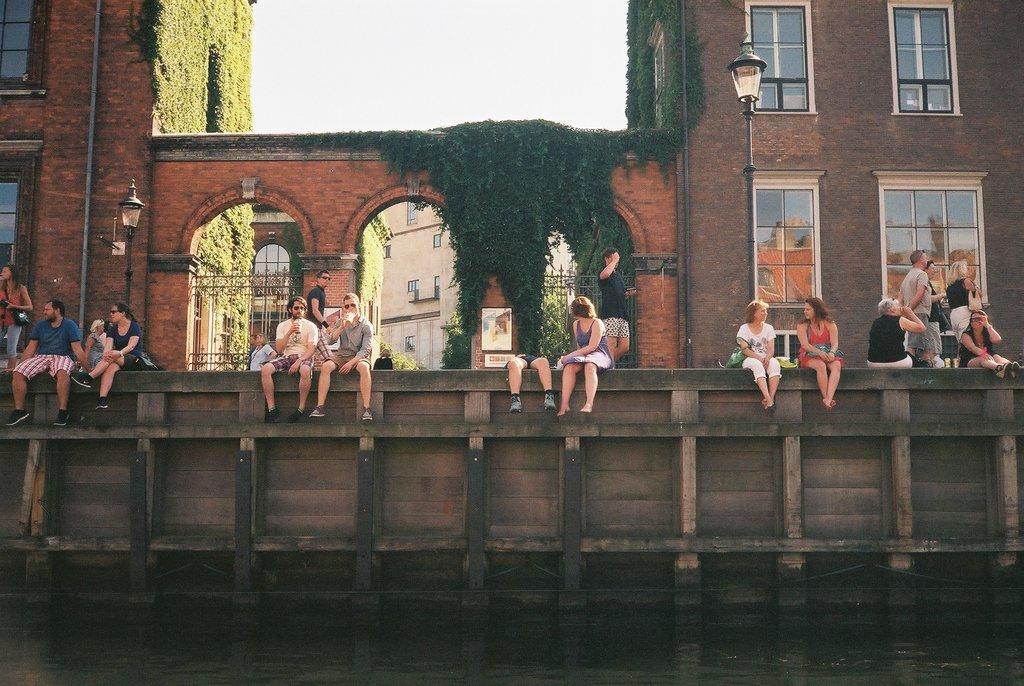Could you give a brief overview of what you see in this image? In this image we can see people sitting on the wall and some of them are holding disposable tumblers in their hands. In the background there are buildings, street poles, street lights, persons standing on the floor, gates, creepers on the walls and sky. 